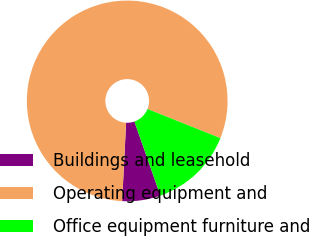Convert chart to OTSL. <chart><loc_0><loc_0><loc_500><loc_500><pie_chart><fcel>Buildings and leasehold<fcel>Operating equipment and<fcel>Office equipment furniture and<nl><fcel>6.17%<fcel>80.25%<fcel>13.58%<nl></chart> 